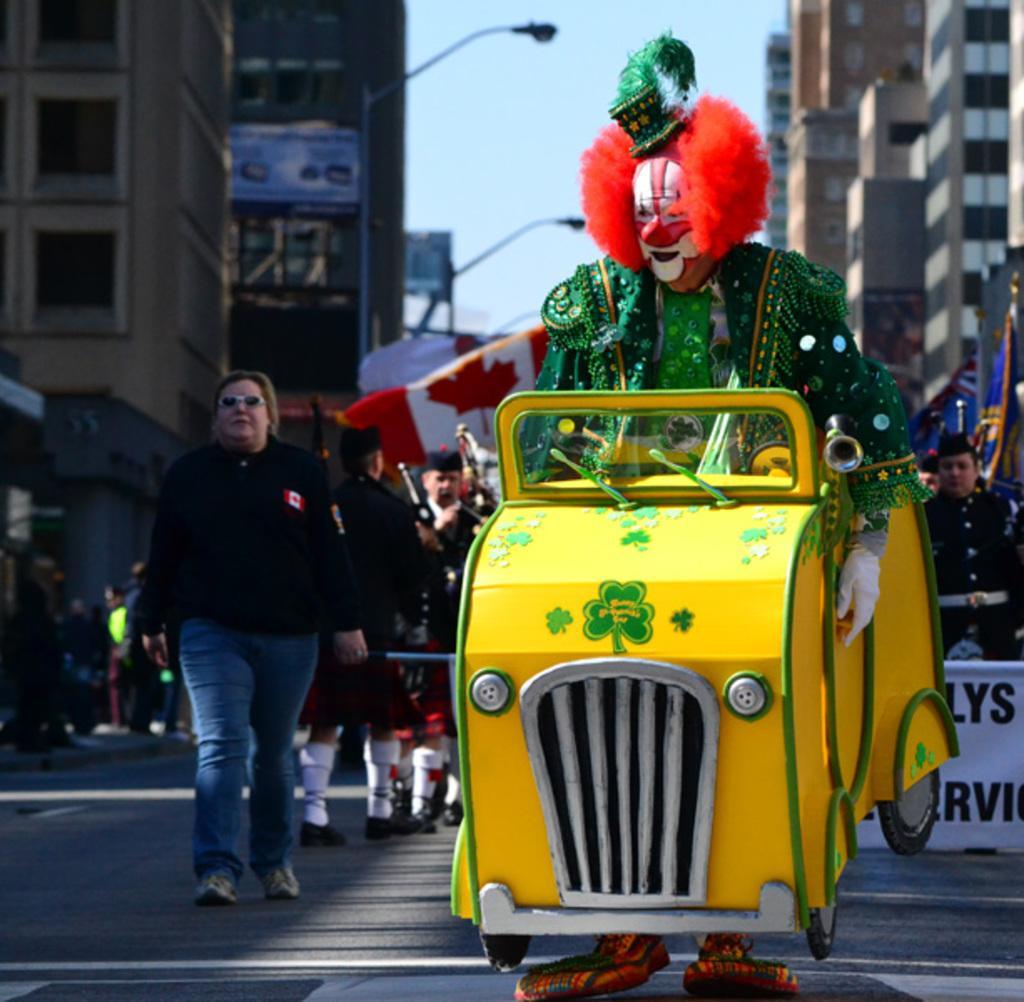Could you give a brief overview of what you see in this image? As we can see in the image there are few people here and there, vehicle, banner, buildings, street lamps and sky. 